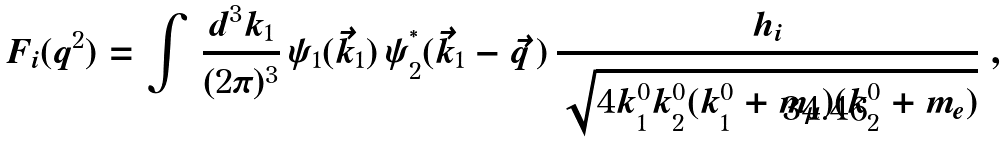<formula> <loc_0><loc_0><loc_500><loc_500>F _ { i } ( q ^ { 2 } ) = \int \, \frac { d ^ { 3 } k _ { 1 } } { ( 2 \pi ) ^ { 3 } } \, \psi _ { 1 } ( \vec { k } _ { 1 } ) \, \psi _ { 2 } ^ { ^ { * } } ( \vec { k } _ { 1 } - \vec { q } \, ) \, \frac { h _ { i } } { \sqrt { 4 k _ { 1 } ^ { 0 } k _ { 2 } ^ { 0 } ( k _ { 1 } ^ { 0 } + m _ { \mu } ) ( k _ { 2 } ^ { 0 } + m _ { e } ) } } \ ,</formula> 